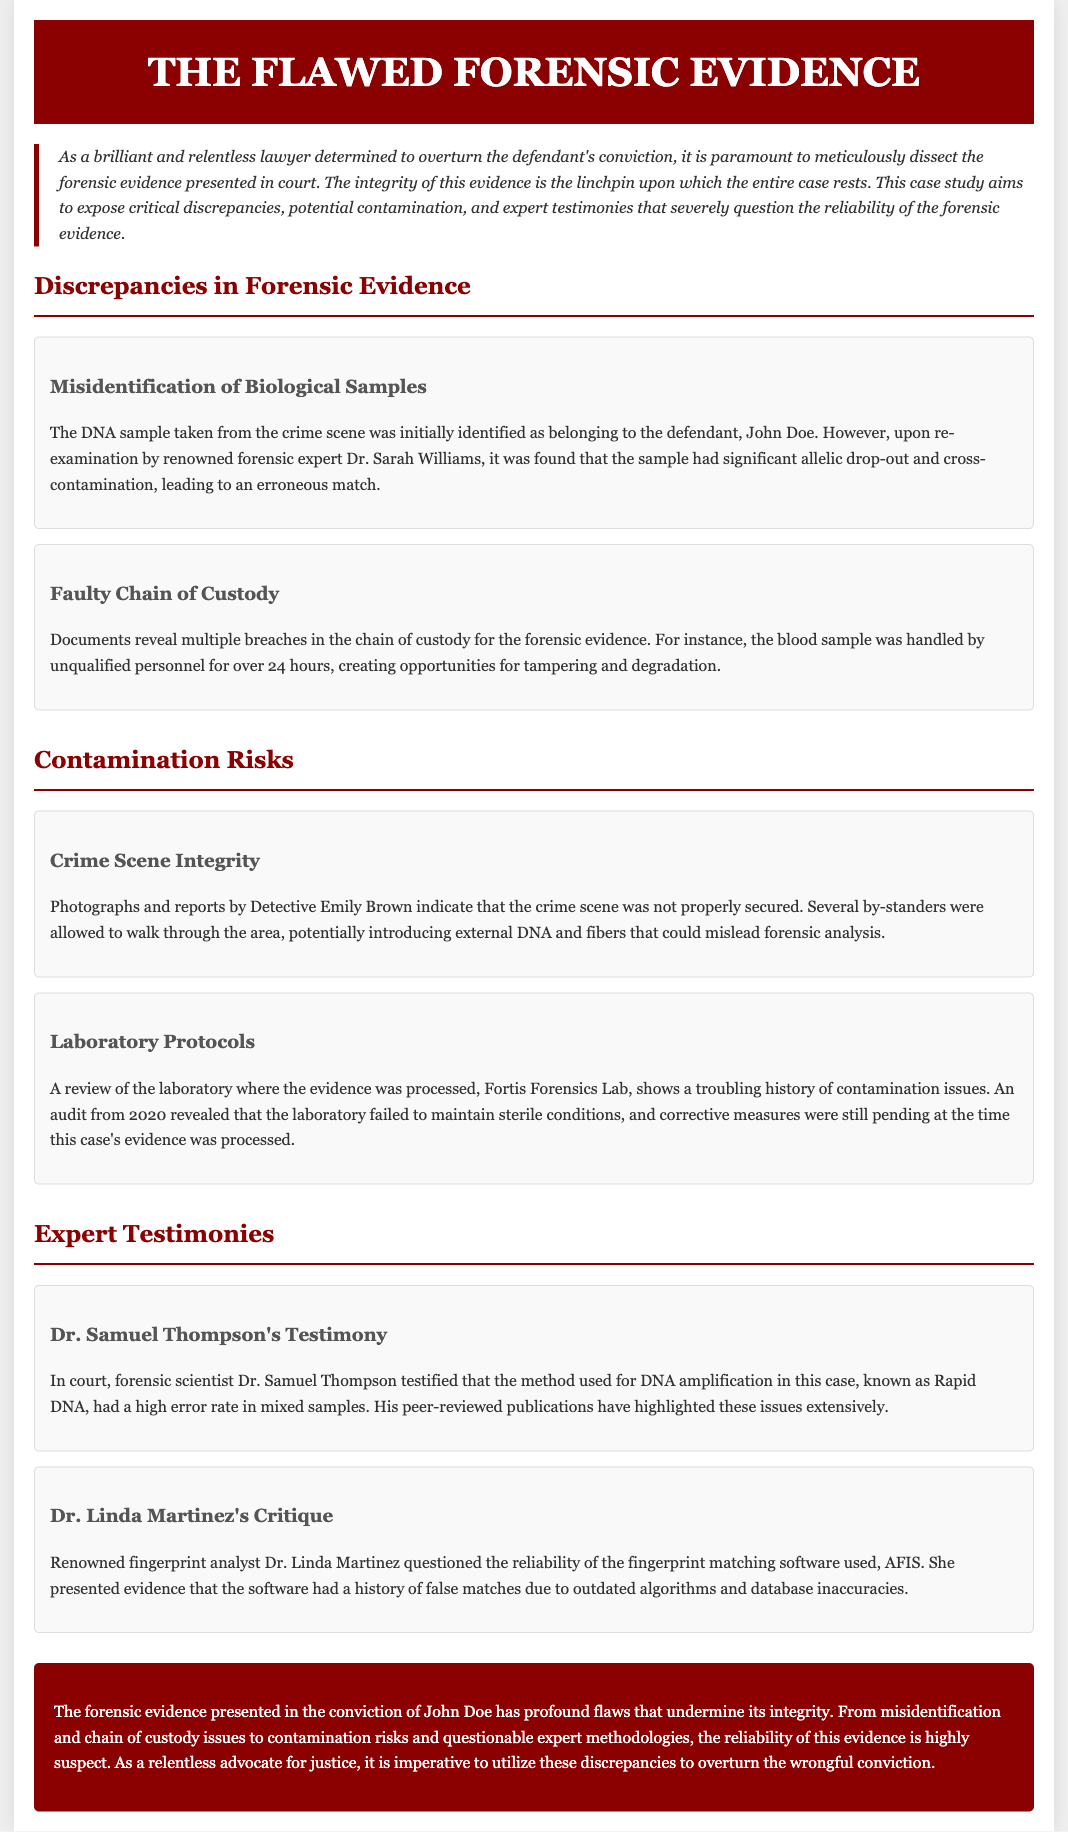What is the name of the forensic expert who re-examined the DNA sample? Dr. Sarah Williams is mentioned in the document as the forensic expert who found issues with the DNA sample.
Answer: Dr. Sarah Williams What was identified as a significant issue with the DNA sample? The document states that the DNA sample had significant allelic drop-out and cross-contamination, leading to an erroneous match.
Answer: Allelic drop-out and cross-contamination What kind of evidence was handled improperly? The blood sample is specifically mentioned as having been handled by unqualified personnel, which is a breach of the chain of custody.
Answer: Blood sample Which laboratory was mentioned in relation to contamination issues? The document refers to Fortis Forensics Lab in connection with this case and its contamination history.
Answer: Fortis Forensics Lab What is the full name of the expert who testified about the DNA amplification method? The document states that Dr. Samuel Thompson testified in court regarding the DNA amplification method.
Answer: Dr. Samuel Thompson What recommended protocol was not maintained at Fortis Forensics Lab? The document indicates that the laboratory failed to maintain sterile conditions, which is a critical protocol issue.
Answer: Sterile conditions How long was the blood sample handled by personnel before being processed? According to the document, the blood sample was handled for over 24 hours by unqualified personnel.
Answer: Over 24 hours What does Dr. Linda Martinez question in her critique? Dr. Linda Martinez questioned the reliability of the fingerprint matching software used, specifically AFIS, due to outdated algorithms.
Answer: Fingerprint matching software What was the conclusion regarding the forensic evidence? The conclusion states that the forensic evidence presented in the conviction of John Doe has profound flaws that undermine its integrity.
Answer: Profound flaws that undermine integrity 